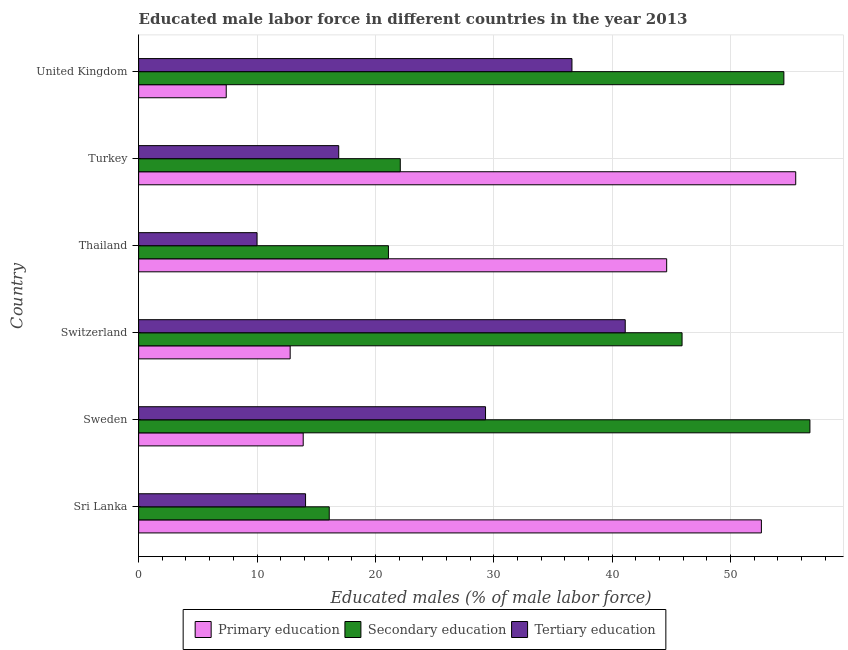Are the number of bars per tick equal to the number of legend labels?
Your answer should be compact. Yes. How many bars are there on the 2nd tick from the top?
Your response must be concise. 3. How many bars are there on the 2nd tick from the bottom?
Your response must be concise. 3. What is the label of the 5th group of bars from the top?
Your answer should be very brief. Sweden. In how many cases, is the number of bars for a given country not equal to the number of legend labels?
Make the answer very short. 0. What is the percentage of male labor force who received primary education in Sweden?
Your response must be concise. 13.9. Across all countries, what is the maximum percentage of male labor force who received tertiary education?
Keep it short and to the point. 41.1. Across all countries, what is the minimum percentage of male labor force who received primary education?
Give a very brief answer. 7.4. What is the total percentage of male labor force who received tertiary education in the graph?
Your response must be concise. 148. What is the difference between the percentage of male labor force who received primary education in Turkey and that in United Kingdom?
Offer a very short reply. 48.1. What is the difference between the percentage of male labor force who received tertiary education in Thailand and the percentage of male labor force who received primary education in Switzerland?
Ensure brevity in your answer.  -2.8. What is the average percentage of male labor force who received tertiary education per country?
Your response must be concise. 24.67. In how many countries, is the percentage of male labor force who received secondary education greater than 54 %?
Keep it short and to the point. 2. What is the ratio of the percentage of male labor force who received secondary education in Thailand to that in United Kingdom?
Your answer should be very brief. 0.39. What is the difference between the highest and the second highest percentage of male labor force who received secondary education?
Ensure brevity in your answer.  2.2. What is the difference between the highest and the lowest percentage of male labor force who received primary education?
Make the answer very short. 48.1. In how many countries, is the percentage of male labor force who received tertiary education greater than the average percentage of male labor force who received tertiary education taken over all countries?
Your answer should be very brief. 3. Is the sum of the percentage of male labor force who received primary education in Sri Lanka and Turkey greater than the maximum percentage of male labor force who received tertiary education across all countries?
Make the answer very short. Yes. What does the 2nd bar from the top in Sweden represents?
Keep it short and to the point. Secondary education. What does the 2nd bar from the bottom in Thailand represents?
Your response must be concise. Secondary education. Is it the case that in every country, the sum of the percentage of male labor force who received primary education and percentage of male labor force who received secondary education is greater than the percentage of male labor force who received tertiary education?
Offer a very short reply. Yes. What is the difference between two consecutive major ticks on the X-axis?
Keep it short and to the point. 10. Does the graph contain any zero values?
Your answer should be compact. No. Where does the legend appear in the graph?
Provide a short and direct response. Bottom center. How many legend labels are there?
Provide a short and direct response. 3. How are the legend labels stacked?
Your answer should be very brief. Horizontal. What is the title of the graph?
Ensure brevity in your answer.  Educated male labor force in different countries in the year 2013. What is the label or title of the X-axis?
Your answer should be compact. Educated males (% of male labor force). What is the Educated males (% of male labor force) in Primary education in Sri Lanka?
Offer a terse response. 52.6. What is the Educated males (% of male labor force) of Secondary education in Sri Lanka?
Your answer should be very brief. 16.1. What is the Educated males (% of male labor force) in Tertiary education in Sri Lanka?
Your answer should be compact. 14.1. What is the Educated males (% of male labor force) in Primary education in Sweden?
Provide a short and direct response. 13.9. What is the Educated males (% of male labor force) of Secondary education in Sweden?
Your answer should be compact. 56.7. What is the Educated males (% of male labor force) of Tertiary education in Sweden?
Your response must be concise. 29.3. What is the Educated males (% of male labor force) in Primary education in Switzerland?
Your response must be concise. 12.8. What is the Educated males (% of male labor force) of Secondary education in Switzerland?
Your answer should be very brief. 45.9. What is the Educated males (% of male labor force) of Tertiary education in Switzerland?
Ensure brevity in your answer.  41.1. What is the Educated males (% of male labor force) of Primary education in Thailand?
Keep it short and to the point. 44.6. What is the Educated males (% of male labor force) of Secondary education in Thailand?
Keep it short and to the point. 21.1. What is the Educated males (% of male labor force) in Primary education in Turkey?
Give a very brief answer. 55.5. What is the Educated males (% of male labor force) in Secondary education in Turkey?
Your response must be concise. 22.1. What is the Educated males (% of male labor force) in Tertiary education in Turkey?
Provide a short and direct response. 16.9. What is the Educated males (% of male labor force) of Primary education in United Kingdom?
Your response must be concise. 7.4. What is the Educated males (% of male labor force) in Secondary education in United Kingdom?
Provide a short and direct response. 54.5. What is the Educated males (% of male labor force) of Tertiary education in United Kingdom?
Ensure brevity in your answer.  36.6. Across all countries, what is the maximum Educated males (% of male labor force) in Primary education?
Give a very brief answer. 55.5. Across all countries, what is the maximum Educated males (% of male labor force) in Secondary education?
Your answer should be very brief. 56.7. Across all countries, what is the maximum Educated males (% of male labor force) of Tertiary education?
Give a very brief answer. 41.1. Across all countries, what is the minimum Educated males (% of male labor force) in Primary education?
Your response must be concise. 7.4. Across all countries, what is the minimum Educated males (% of male labor force) in Secondary education?
Provide a short and direct response. 16.1. What is the total Educated males (% of male labor force) in Primary education in the graph?
Your answer should be compact. 186.8. What is the total Educated males (% of male labor force) of Secondary education in the graph?
Provide a succinct answer. 216.4. What is the total Educated males (% of male labor force) in Tertiary education in the graph?
Give a very brief answer. 148. What is the difference between the Educated males (% of male labor force) in Primary education in Sri Lanka and that in Sweden?
Your answer should be very brief. 38.7. What is the difference between the Educated males (% of male labor force) in Secondary education in Sri Lanka and that in Sweden?
Your answer should be compact. -40.6. What is the difference between the Educated males (% of male labor force) of Tertiary education in Sri Lanka and that in Sweden?
Ensure brevity in your answer.  -15.2. What is the difference between the Educated males (% of male labor force) of Primary education in Sri Lanka and that in Switzerland?
Ensure brevity in your answer.  39.8. What is the difference between the Educated males (% of male labor force) in Secondary education in Sri Lanka and that in Switzerland?
Offer a terse response. -29.8. What is the difference between the Educated males (% of male labor force) of Tertiary education in Sri Lanka and that in Switzerland?
Make the answer very short. -27. What is the difference between the Educated males (% of male labor force) in Secondary education in Sri Lanka and that in Turkey?
Offer a terse response. -6. What is the difference between the Educated males (% of male labor force) of Tertiary education in Sri Lanka and that in Turkey?
Offer a terse response. -2.8. What is the difference between the Educated males (% of male labor force) in Primary education in Sri Lanka and that in United Kingdom?
Keep it short and to the point. 45.2. What is the difference between the Educated males (% of male labor force) of Secondary education in Sri Lanka and that in United Kingdom?
Ensure brevity in your answer.  -38.4. What is the difference between the Educated males (% of male labor force) of Tertiary education in Sri Lanka and that in United Kingdom?
Offer a terse response. -22.5. What is the difference between the Educated males (% of male labor force) of Tertiary education in Sweden and that in Switzerland?
Your answer should be compact. -11.8. What is the difference between the Educated males (% of male labor force) in Primary education in Sweden and that in Thailand?
Give a very brief answer. -30.7. What is the difference between the Educated males (% of male labor force) in Secondary education in Sweden and that in Thailand?
Provide a succinct answer. 35.6. What is the difference between the Educated males (% of male labor force) of Tertiary education in Sweden and that in Thailand?
Your answer should be very brief. 19.3. What is the difference between the Educated males (% of male labor force) in Primary education in Sweden and that in Turkey?
Give a very brief answer. -41.6. What is the difference between the Educated males (% of male labor force) in Secondary education in Sweden and that in Turkey?
Provide a succinct answer. 34.6. What is the difference between the Educated males (% of male labor force) of Primary education in Sweden and that in United Kingdom?
Your answer should be compact. 6.5. What is the difference between the Educated males (% of male labor force) in Secondary education in Sweden and that in United Kingdom?
Offer a terse response. 2.2. What is the difference between the Educated males (% of male labor force) in Tertiary education in Sweden and that in United Kingdom?
Make the answer very short. -7.3. What is the difference between the Educated males (% of male labor force) in Primary education in Switzerland and that in Thailand?
Provide a succinct answer. -31.8. What is the difference between the Educated males (% of male labor force) in Secondary education in Switzerland and that in Thailand?
Your answer should be very brief. 24.8. What is the difference between the Educated males (% of male labor force) of Tertiary education in Switzerland and that in Thailand?
Provide a succinct answer. 31.1. What is the difference between the Educated males (% of male labor force) in Primary education in Switzerland and that in Turkey?
Provide a succinct answer. -42.7. What is the difference between the Educated males (% of male labor force) of Secondary education in Switzerland and that in Turkey?
Keep it short and to the point. 23.8. What is the difference between the Educated males (% of male labor force) in Tertiary education in Switzerland and that in Turkey?
Ensure brevity in your answer.  24.2. What is the difference between the Educated males (% of male labor force) of Primary education in Thailand and that in United Kingdom?
Give a very brief answer. 37.2. What is the difference between the Educated males (% of male labor force) of Secondary education in Thailand and that in United Kingdom?
Your answer should be very brief. -33.4. What is the difference between the Educated males (% of male labor force) in Tertiary education in Thailand and that in United Kingdom?
Ensure brevity in your answer.  -26.6. What is the difference between the Educated males (% of male labor force) in Primary education in Turkey and that in United Kingdom?
Make the answer very short. 48.1. What is the difference between the Educated males (% of male labor force) in Secondary education in Turkey and that in United Kingdom?
Offer a terse response. -32.4. What is the difference between the Educated males (% of male labor force) in Tertiary education in Turkey and that in United Kingdom?
Your response must be concise. -19.7. What is the difference between the Educated males (% of male labor force) of Primary education in Sri Lanka and the Educated males (% of male labor force) of Secondary education in Sweden?
Your answer should be very brief. -4.1. What is the difference between the Educated males (% of male labor force) of Primary education in Sri Lanka and the Educated males (% of male labor force) of Tertiary education in Sweden?
Offer a very short reply. 23.3. What is the difference between the Educated males (% of male labor force) in Primary education in Sri Lanka and the Educated males (% of male labor force) in Secondary education in Switzerland?
Offer a very short reply. 6.7. What is the difference between the Educated males (% of male labor force) in Secondary education in Sri Lanka and the Educated males (% of male labor force) in Tertiary education in Switzerland?
Ensure brevity in your answer.  -25. What is the difference between the Educated males (% of male labor force) of Primary education in Sri Lanka and the Educated males (% of male labor force) of Secondary education in Thailand?
Keep it short and to the point. 31.5. What is the difference between the Educated males (% of male labor force) of Primary education in Sri Lanka and the Educated males (% of male labor force) of Tertiary education in Thailand?
Keep it short and to the point. 42.6. What is the difference between the Educated males (% of male labor force) in Primary education in Sri Lanka and the Educated males (% of male labor force) in Secondary education in Turkey?
Offer a terse response. 30.5. What is the difference between the Educated males (% of male labor force) in Primary education in Sri Lanka and the Educated males (% of male labor force) in Tertiary education in Turkey?
Offer a very short reply. 35.7. What is the difference between the Educated males (% of male labor force) in Primary education in Sri Lanka and the Educated males (% of male labor force) in Secondary education in United Kingdom?
Give a very brief answer. -1.9. What is the difference between the Educated males (% of male labor force) in Primary education in Sri Lanka and the Educated males (% of male labor force) in Tertiary education in United Kingdom?
Offer a terse response. 16. What is the difference between the Educated males (% of male labor force) in Secondary education in Sri Lanka and the Educated males (% of male labor force) in Tertiary education in United Kingdom?
Your response must be concise. -20.5. What is the difference between the Educated males (% of male labor force) of Primary education in Sweden and the Educated males (% of male labor force) of Secondary education in Switzerland?
Provide a succinct answer. -32. What is the difference between the Educated males (% of male labor force) of Primary education in Sweden and the Educated males (% of male labor force) of Tertiary education in Switzerland?
Provide a short and direct response. -27.2. What is the difference between the Educated males (% of male labor force) in Primary education in Sweden and the Educated males (% of male labor force) in Secondary education in Thailand?
Offer a terse response. -7.2. What is the difference between the Educated males (% of male labor force) in Primary education in Sweden and the Educated males (% of male labor force) in Tertiary education in Thailand?
Offer a terse response. 3.9. What is the difference between the Educated males (% of male labor force) of Secondary education in Sweden and the Educated males (% of male labor force) of Tertiary education in Thailand?
Ensure brevity in your answer.  46.7. What is the difference between the Educated males (% of male labor force) of Primary education in Sweden and the Educated males (% of male labor force) of Secondary education in Turkey?
Offer a terse response. -8.2. What is the difference between the Educated males (% of male labor force) of Primary education in Sweden and the Educated males (% of male labor force) of Tertiary education in Turkey?
Provide a short and direct response. -3. What is the difference between the Educated males (% of male labor force) in Secondary education in Sweden and the Educated males (% of male labor force) in Tertiary education in Turkey?
Make the answer very short. 39.8. What is the difference between the Educated males (% of male labor force) in Primary education in Sweden and the Educated males (% of male labor force) in Secondary education in United Kingdom?
Provide a succinct answer. -40.6. What is the difference between the Educated males (% of male labor force) in Primary education in Sweden and the Educated males (% of male labor force) in Tertiary education in United Kingdom?
Provide a succinct answer. -22.7. What is the difference between the Educated males (% of male labor force) in Secondary education in Sweden and the Educated males (% of male labor force) in Tertiary education in United Kingdom?
Offer a very short reply. 20.1. What is the difference between the Educated males (% of male labor force) of Primary education in Switzerland and the Educated males (% of male labor force) of Secondary education in Thailand?
Your response must be concise. -8.3. What is the difference between the Educated males (% of male labor force) in Primary education in Switzerland and the Educated males (% of male labor force) in Tertiary education in Thailand?
Provide a succinct answer. 2.8. What is the difference between the Educated males (% of male labor force) in Secondary education in Switzerland and the Educated males (% of male labor force) in Tertiary education in Thailand?
Your answer should be very brief. 35.9. What is the difference between the Educated males (% of male labor force) in Primary education in Switzerland and the Educated males (% of male labor force) in Secondary education in Turkey?
Provide a succinct answer. -9.3. What is the difference between the Educated males (% of male labor force) in Primary education in Switzerland and the Educated males (% of male labor force) in Tertiary education in Turkey?
Make the answer very short. -4.1. What is the difference between the Educated males (% of male labor force) in Primary education in Switzerland and the Educated males (% of male labor force) in Secondary education in United Kingdom?
Offer a very short reply. -41.7. What is the difference between the Educated males (% of male labor force) of Primary education in Switzerland and the Educated males (% of male labor force) of Tertiary education in United Kingdom?
Your answer should be compact. -23.8. What is the difference between the Educated males (% of male labor force) in Secondary education in Switzerland and the Educated males (% of male labor force) in Tertiary education in United Kingdom?
Provide a short and direct response. 9.3. What is the difference between the Educated males (% of male labor force) in Primary education in Thailand and the Educated males (% of male labor force) in Secondary education in Turkey?
Offer a terse response. 22.5. What is the difference between the Educated males (% of male labor force) of Primary education in Thailand and the Educated males (% of male labor force) of Tertiary education in Turkey?
Your response must be concise. 27.7. What is the difference between the Educated males (% of male labor force) in Primary education in Thailand and the Educated males (% of male labor force) in Tertiary education in United Kingdom?
Keep it short and to the point. 8. What is the difference between the Educated males (% of male labor force) of Secondary education in Thailand and the Educated males (% of male labor force) of Tertiary education in United Kingdom?
Offer a very short reply. -15.5. What is the difference between the Educated males (% of male labor force) in Primary education in Turkey and the Educated males (% of male labor force) in Secondary education in United Kingdom?
Offer a terse response. 1. What is the average Educated males (% of male labor force) of Primary education per country?
Give a very brief answer. 31.13. What is the average Educated males (% of male labor force) in Secondary education per country?
Offer a terse response. 36.07. What is the average Educated males (% of male labor force) in Tertiary education per country?
Keep it short and to the point. 24.67. What is the difference between the Educated males (% of male labor force) in Primary education and Educated males (% of male labor force) in Secondary education in Sri Lanka?
Your answer should be compact. 36.5. What is the difference between the Educated males (% of male labor force) of Primary education and Educated males (% of male labor force) of Tertiary education in Sri Lanka?
Keep it short and to the point. 38.5. What is the difference between the Educated males (% of male labor force) in Primary education and Educated males (% of male labor force) in Secondary education in Sweden?
Your response must be concise. -42.8. What is the difference between the Educated males (% of male labor force) of Primary education and Educated males (% of male labor force) of Tertiary education in Sweden?
Offer a terse response. -15.4. What is the difference between the Educated males (% of male labor force) in Secondary education and Educated males (% of male labor force) in Tertiary education in Sweden?
Ensure brevity in your answer.  27.4. What is the difference between the Educated males (% of male labor force) of Primary education and Educated males (% of male labor force) of Secondary education in Switzerland?
Your response must be concise. -33.1. What is the difference between the Educated males (% of male labor force) in Primary education and Educated males (% of male labor force) in Tertiary education in Switzerland?
Provide a short and direct response. -28.3. What is the difference between the Educated males (% of male labor force) in Primary education and Educated males (% of male labor force) in Tertiary education in Thailand?
Offer a terse response. 34.6. What is the difference between the Educated males (% of male labor force) in Primary education and Educated males (% of male labor force) in Secondary education in Turkey?
Give a very brief answer. 33.4. What is the difference between the Educated males (% of male labor force) of Primary education and Educated males (% of male labor force) of Tertiary education in Turkey?
Offer a very short reply. 38.6. What is the difference between the Educated males (% of male labor force) of Secondary education and Educated males (% of male labor force) of Tertiary education in Turkey?
Offer a very short reply. 5.2. What is the difference between the Educated males (% of male labor force) of Primary education and Educated males (% of male labor force) of Secondary education in United Kingdom?
Provide a succinct answer. -47.1. What is the difference between the Educated males (% of male labor force) in Primary education and Educated males (% of male labor force) in Tertiary education in United Kingdom?
Offer a terse response. -29.2. What is the ratio of the Educated males (% of male labor force) in Primary education in Sri Lanka to that in Sweden?
Your response must be concise. 3.78. What is the ratio of the Educated males (% of male labor force) in Secondary education in Sri Lanka to that in Sweden?
Provide a short and direct response. 0.28. What is the ratio of the Educated males (% of male labor force) of Tertiary education in Sri Lanka to that in Sweden?
Your answer should be compact. 0.48. What is the ratio of the Educated males (% of male labor force) in Primary education in Sri Lanka to that in Switzerland?
Ensure brevity in your answer.  4.11. What is the ratio of the Educated males (% of male labor force) in Secondary education in Sri Lanka to that in Switzerland?
Keep it short and to the point. 0.35. What is the ratio of the Educated males (% of male labor force) of Tertiary education in Sri Lanka to that in Switzerland?
Provide a succinct answer. 0.34. What is the ratio of the Educated males (% of male labor force) in Primary education in Sri Lanka to that in Thailand?
Your response must be concise. 1.18. What is the ratio of the Educated males (% of male labor force) of Secondary education in Sri Lanka to that in Thailand?
Give a very brief answer. 0.76. What is the ratio of the Educated males (% of male labor force) in Tertiary education in Sri Lanka to that in Thailand?
Provide a succinct answer. 1.41. What is the ratio of the Educated males (% of male labor force) in Primary education in Sri Lanka to that in Turkey?
Offer a terse response. 0.95. What is the ratio of the Educated males (% of male labor force) of Secondary education in Sri Lanka to that in Turkey?
Provide a succinct answer. 0.73. What is the ratio of the Educated males (% of male labor force) in Tertiary education in Sri Lanka to that in Turkey?
Offer a very short reply. 0.83. What is the ratio of the Educated males (% of male labor force) in Primary education in Sri Lanka to that in United Kingdom?
Ensure brevity in your answer.  7.11. What is the ratio of the Educated males (% of male labor force) in Secondary education in Sri Lanka to that in United Kingdom?
Offer a very short reply. 0.3. What is the ratio of the Educated males (% of male labor force) of Tertiary education in Sri Lanka to that in United Kingdom?
Provide a short and direct response. 0.39. What is the ratio of the Educated males (% of male labor force) in Primary education in Sweden to that in Switzerland?
Give a very brief answer. 1.09. What is the ratio of the Educated males (% of male labor force) in Secondary education in Sweden to that in Switzerland?
Ensure brevity in your answer.  1.24. What is the ratio of the Educated males (% of male labor force) of Tertiary education in Sweden to that in Switzerland?
Your answer should be very brief. 0.71. What is the ratio of the Educated males (% of male labor force) in Primary education in Sweden to that in Thailand?
Offer a very short reply. 0.31. What is the ratio of the Educated males (% of male labor force) of Secondary education in Sweden to that in Thailand?
Your response must be concise. 2.69. What is the ratio of the Educated males (% of male labor force) of Tertiary education in Sweden to that in Thailand?
Provide a succinct answer. 2.93. What is the ratio of the Educated males (% of male labor force) of Primary education in Sweden to that in Turkey?
Provide a succinct answer. 0.25. What is the ratio of the Educated males (% of male labor force) of Secondary education in Sweden to that in Turkey?
Your response must be concise. 2.57. What is the ratio of the Educated males (% of male labor force) in Tertiary education in Sweden to that in Turkey?
Provide a short and direct response. 1.73. What is the ratio of the Educated males (% of male labor force) of Primary education in Sweden to that in United Kingdom?
Your answer should be compact. 1.88. What is the ratio of the Educated males (% of male labor force) in Secondary education in Sweden to that in United Kingdom?
Your answer should be compact. 1.04. What is the ratio of the Educated males (% of male labor force) of Tertiary education in Sweden to that in United Kingdom?
Offer a terse response. 0.8. What is the ratio of the Educated males (% of male labor force) in Primary education in Switzerland to that in Thailand?
Your response must be concise. 0.29. What is the ratio of the Educated males (% of male labor force) of Secondary education in Switzerland to that in Thailand?
Your response must be concise. 2.18. What is the ratio of the Educated males (% of male labor force) in Tertiary education in Switzerland to that in Thailand?
Ensure brevity in your answer.  4.11. What is the ratio of the Educated males (% of male labor force) of Primary education in Switzerland to that in Turkey?
Provide a succinct answer. 0.23. What is the ratio of the Educated males (% of male labor force) of Secondary education in Switzerland to that in Turkey?
Your response must be concise. 2.08. What is the ratio of the Educated males (% of male labor force) in Tertiary education in Switzerland to that in Turkey?
Keep it short and to the point. 2.43. What is the ratio of the Educated males (% of male labor force) in Primary education in Switzerland to that in United Kingdom?
Your answer should be very brief. 1.73. What is the ratio of the Educated males (% of male labor force) in Secondary education in Switzerland to that in United Kingdom?
Offer a very short reply. 0.84. What is the ratio of the Educated males (% of male labor force) of Tertiary education in Switzerland to that in United Kingdom?
Offer a very short reply. 1.12. What is the ratio of the Educated males (% of male labor force) in Primary education in Thailand to that in Turkey?
Your answer should be very brief. 0.8. What is the ratio of the Educated males (% of male labor force) in Secondary education in Thailand to that in Turkey?
Your answer should be compact. 0.95. What is the ratio of the Educated males (% of male labor force) of Tertiary education in Thailand to that in Turkey?
Your response must be concise. 0.59. What is the ratio of the Educated males (% of male labor force) of Primary education in Thailand to that in United Kingdom?
Your answer should be very brief. 6.03. What is the ratio of the Educated males (% of male labor force) in Secondary education in Thailand to that in United Kingdom?
Offer a very short reply. 0.39. What is the ratio of the Educated males (% of male labor force) in Tertiary education in Thailand to that in United Kingdom?
Offer a very short reply. 0.27. What is the ratio of the Educated males (% of male labor force) of Secondary education in Turkey to that in United Kingdom?
Make the answer very short. 0.41. What is the ratio of the Educated males (% of male labor force) of Tertiary education in Turkey to that in United Kingdom?
Make the answer very short. 0.46. What is the difference between the highest and the second highest Educated males (% of male labor force) in Primary education?
Your answer should be very brief. 2.9. What is the difference between the highest and the second highest Educated males (% of male labor force) of Secondary education?
Offer a terse response. 2.2. What is the difference between the highest and the lowest Educated males (% of male labor force) in Primary education?
Your answer should be very brief. 48.1. What is the difference between the highest and the lowest Educated males (% of male labor force) of Secondary education?
Provide a succinct answer. 40.6. What is the difference between the highest and the lowest Educated males (% of male labor force) in Tertiary education?
Provide a short and direct response. 31.1. 